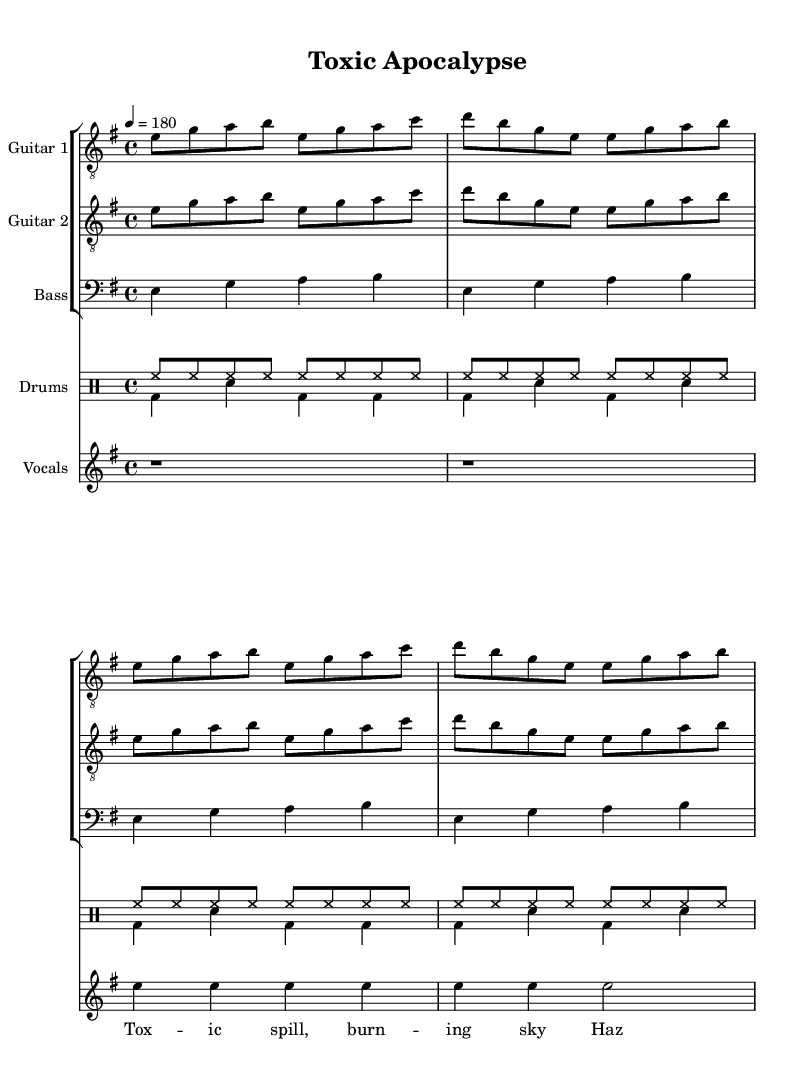What is the key signature of this music? The key signature is found at the beginning of the staff, indicating the sharps or flats in use. In this case, the E minor key signature has one sharp, which is F#.
Answer: E minor What is the time signature of this music? The time signature is shown at the beginning in the form of two numbers, with the upper number indicating the number of beats in a measure and the lower number indicating the note that receives one beat. In this case, it is 4/4.
Answer: 4/4 What is the tempo marking of this piece? The tempo marking, indicated by the beats per minute, is usually found at the beginning of the score. Here, it states "4 = 180", meaning 180 beats per minute.
Answer: 180 How many measures are there in the guitar part? To determine the number of measures, one counts the repeating structures in the music. The guitar part repeats two times, which contains 2 measures each for a total of 4 measures.
Answer: 4 What is the primary theme depicted in the lyrics? The lyrics convey a clear message of danger and urgency regarding hazardous materials, specifically stating the consequences of a toxic spill. The phrases mention burning skies and hazardous waste leading to dire outcomes.
Answer: Toxic spill Identify the instrumental section that maintains the rhythm throughout the piece. In this piece, the drums serve as the backbone for maintaining the rhythm. They have a specific pattern that persists and supports the rest of the instruments.
Answer: Drums What type of metal genre does this song fall into? The characteristics of fast tempos, aggressive guitar riffs, and themes of disaster categorize this song as thrash metal, a sub-genre known for its high energy and incisive lyrics.
Answer: Thrash metal 